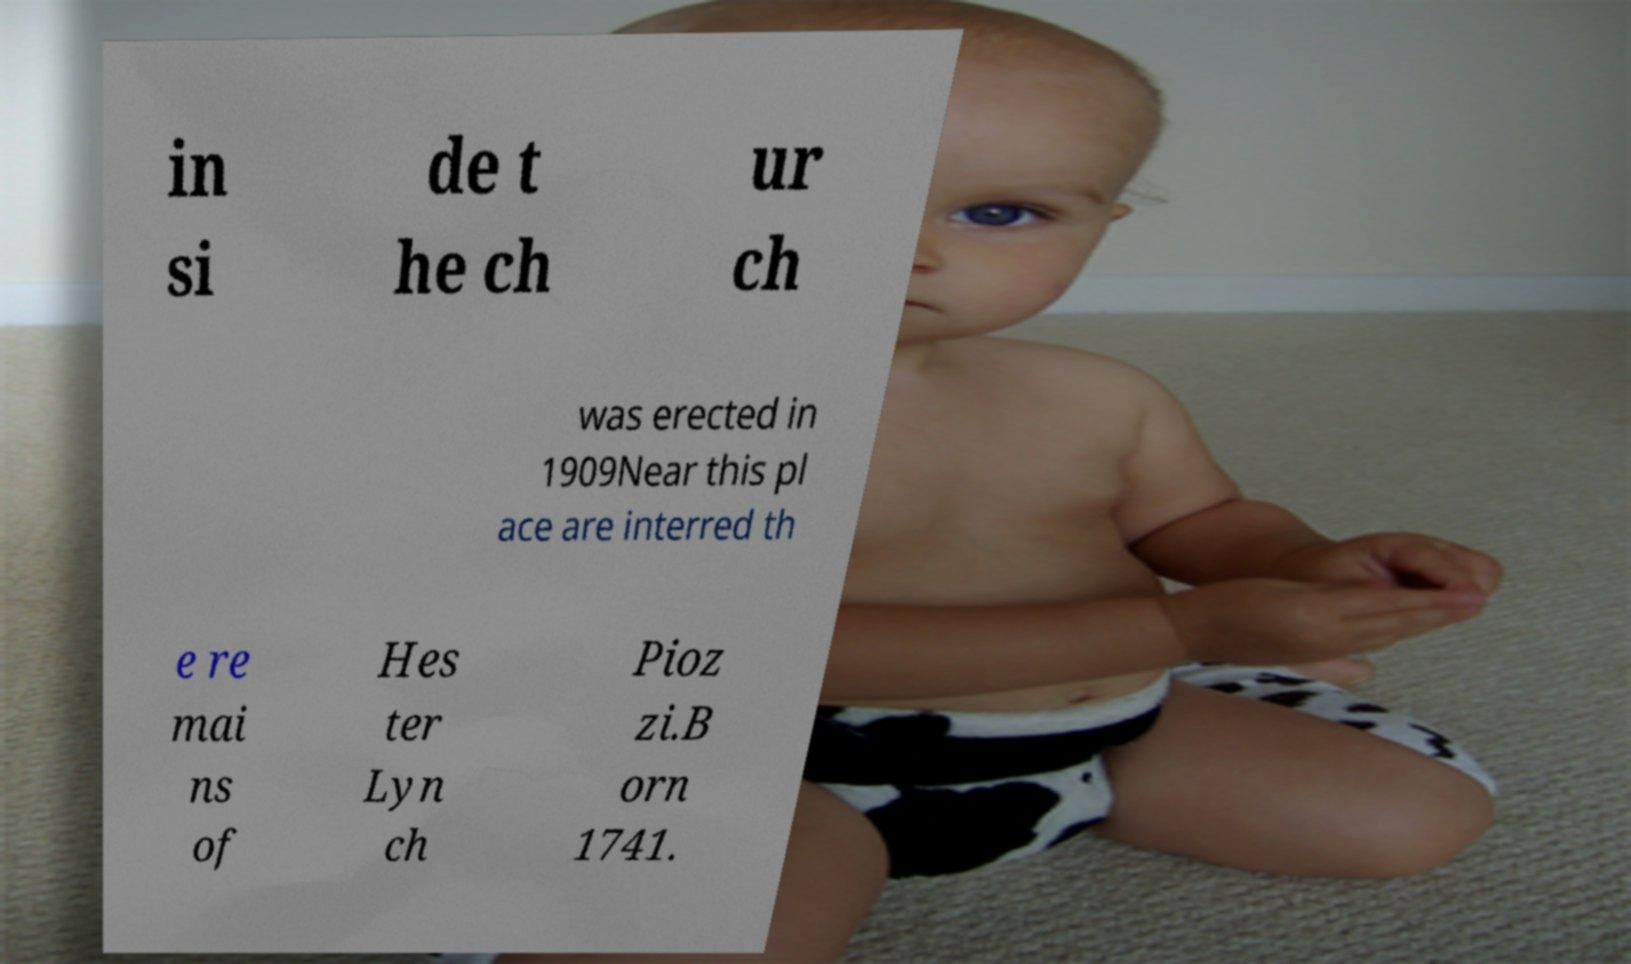Could you assist in decoding the text presented in this image and type it out clearly? in si de t he ch ur ch was erected in 1909Near this pl ace are interred th e re mai ns of Hes ter Lyn ch Pioz zi.B orn 1741. 